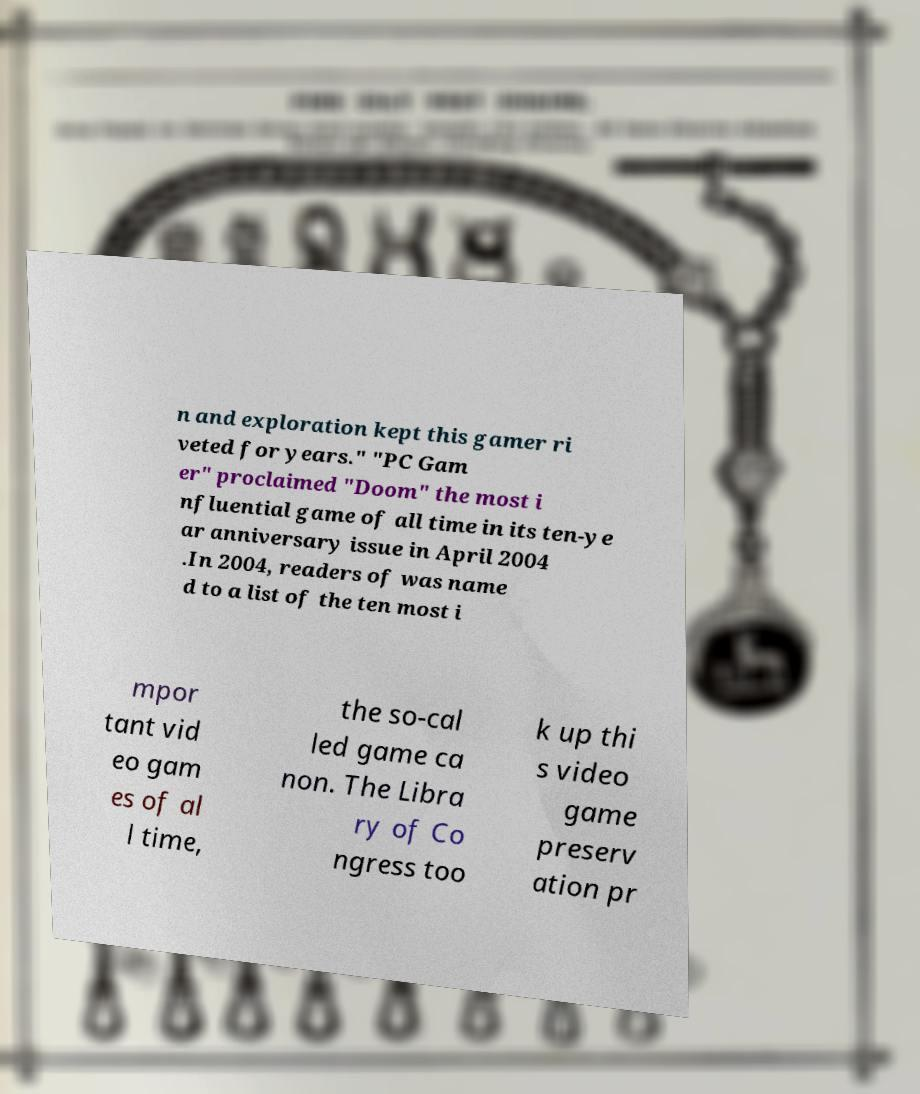Please read and relay the text visible in this image. What does it say? n and exploration kept this gamer ri veted for years." "PC Gam er" proclaimed "Doom" the most i nfluential game of all time in its ten-ye ar anniversary issue in April 2004 .In 2004, readers of was name d to a list of the ten most i mpor tant vid eo gam es of al l time, the so-cal led game ca non. The Libra ry of Co ngress too k up thi s video game preserv ation pr 